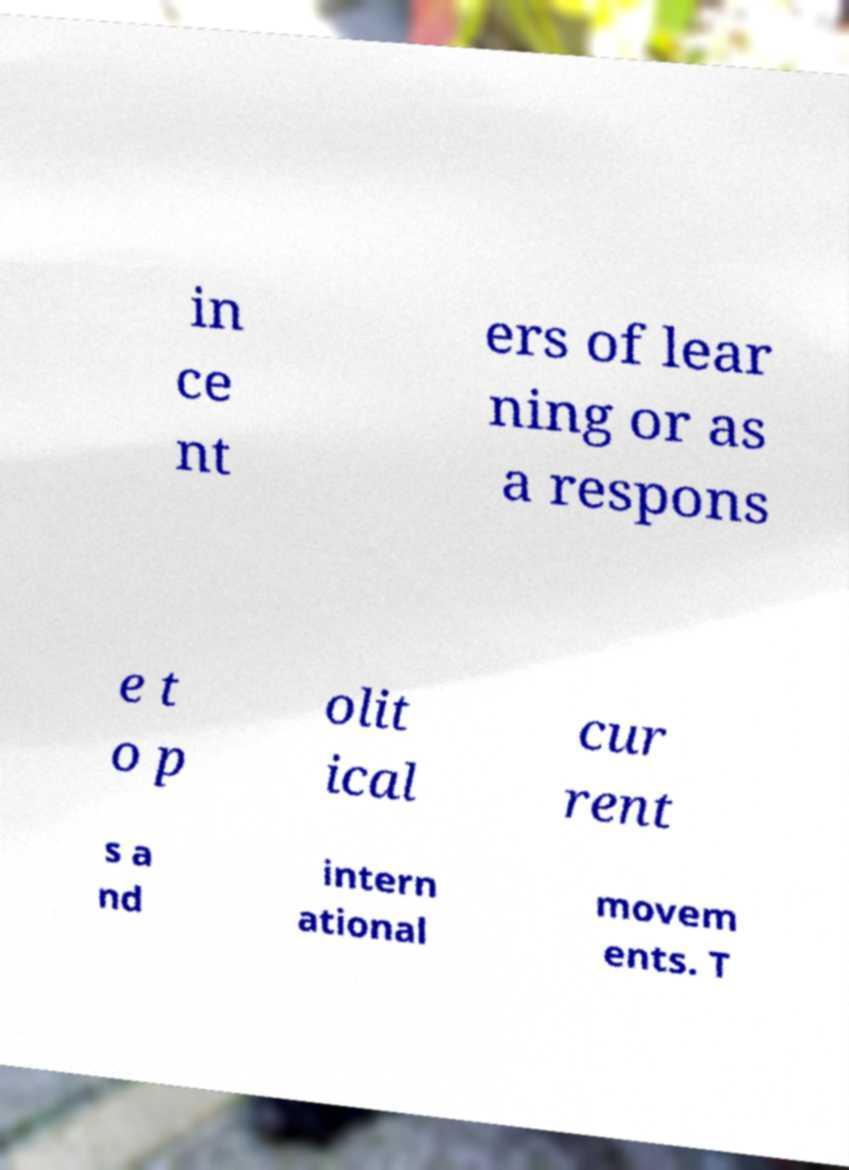There's text embedded in this image that I need extracted. Can you transcribe it verbatim? in ce nt ers of lear ning or as a respons e t o p olit ical cur rent s a nd intern ational movem ents. T 